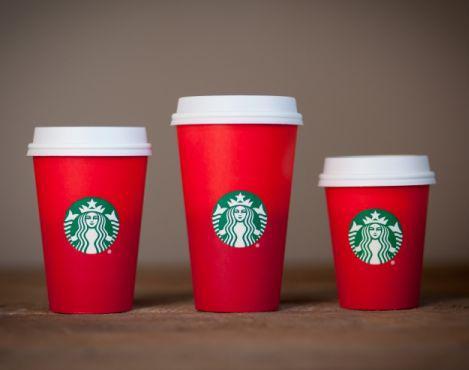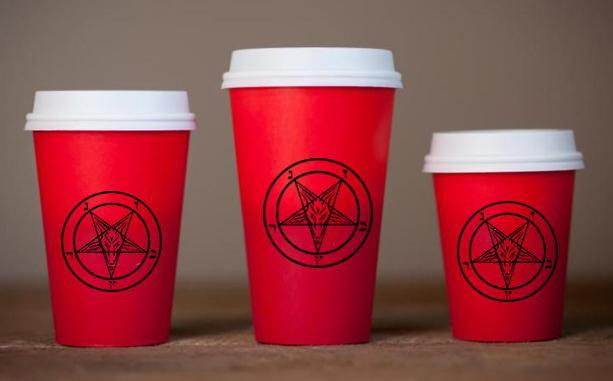The first image is the image on the left, the second image is the image on the right. Examine the images to the left and right. Is the description "There are exactly two cups." accurate? Answer yes or no. No. 